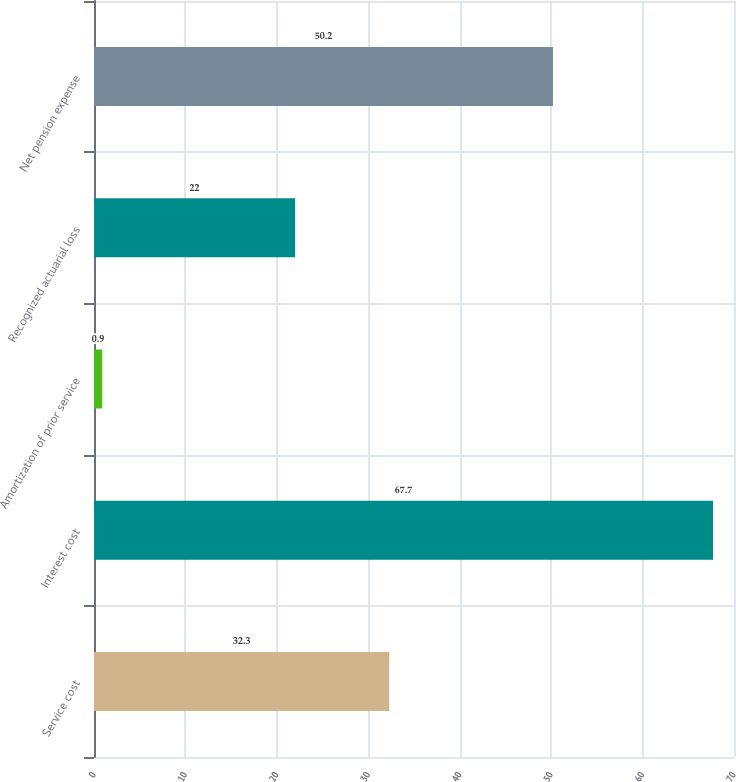Convert chart to OTSL. <chart><loc_0><loc_0><loc_500><loc_500><bar_chart><fcel>Service cost<fcel>Interest cost<fcel>Amortization of prior service<fcel>Recognized actuarial loss<fcel>Net pension expense<nl><fcel>32.3<fcel>67.7<fcel>0.9<fcel>22<fcel>50.2<nl></chart> 